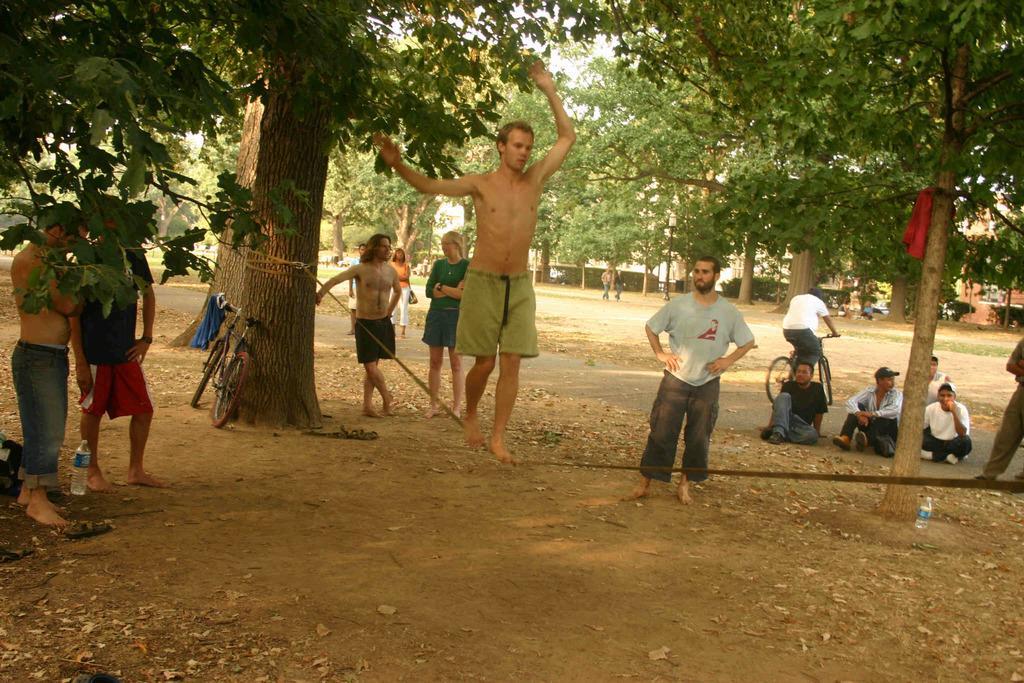Please provide a concise description of this image. As we can see in the image there are lot of trees and on the ground there is a mud and there are people who are standing and sitting. A man is wearing a shorts and he is walking on the rope which is tied to a tree and there is bicycle over here and there is a water bottle between two men. 